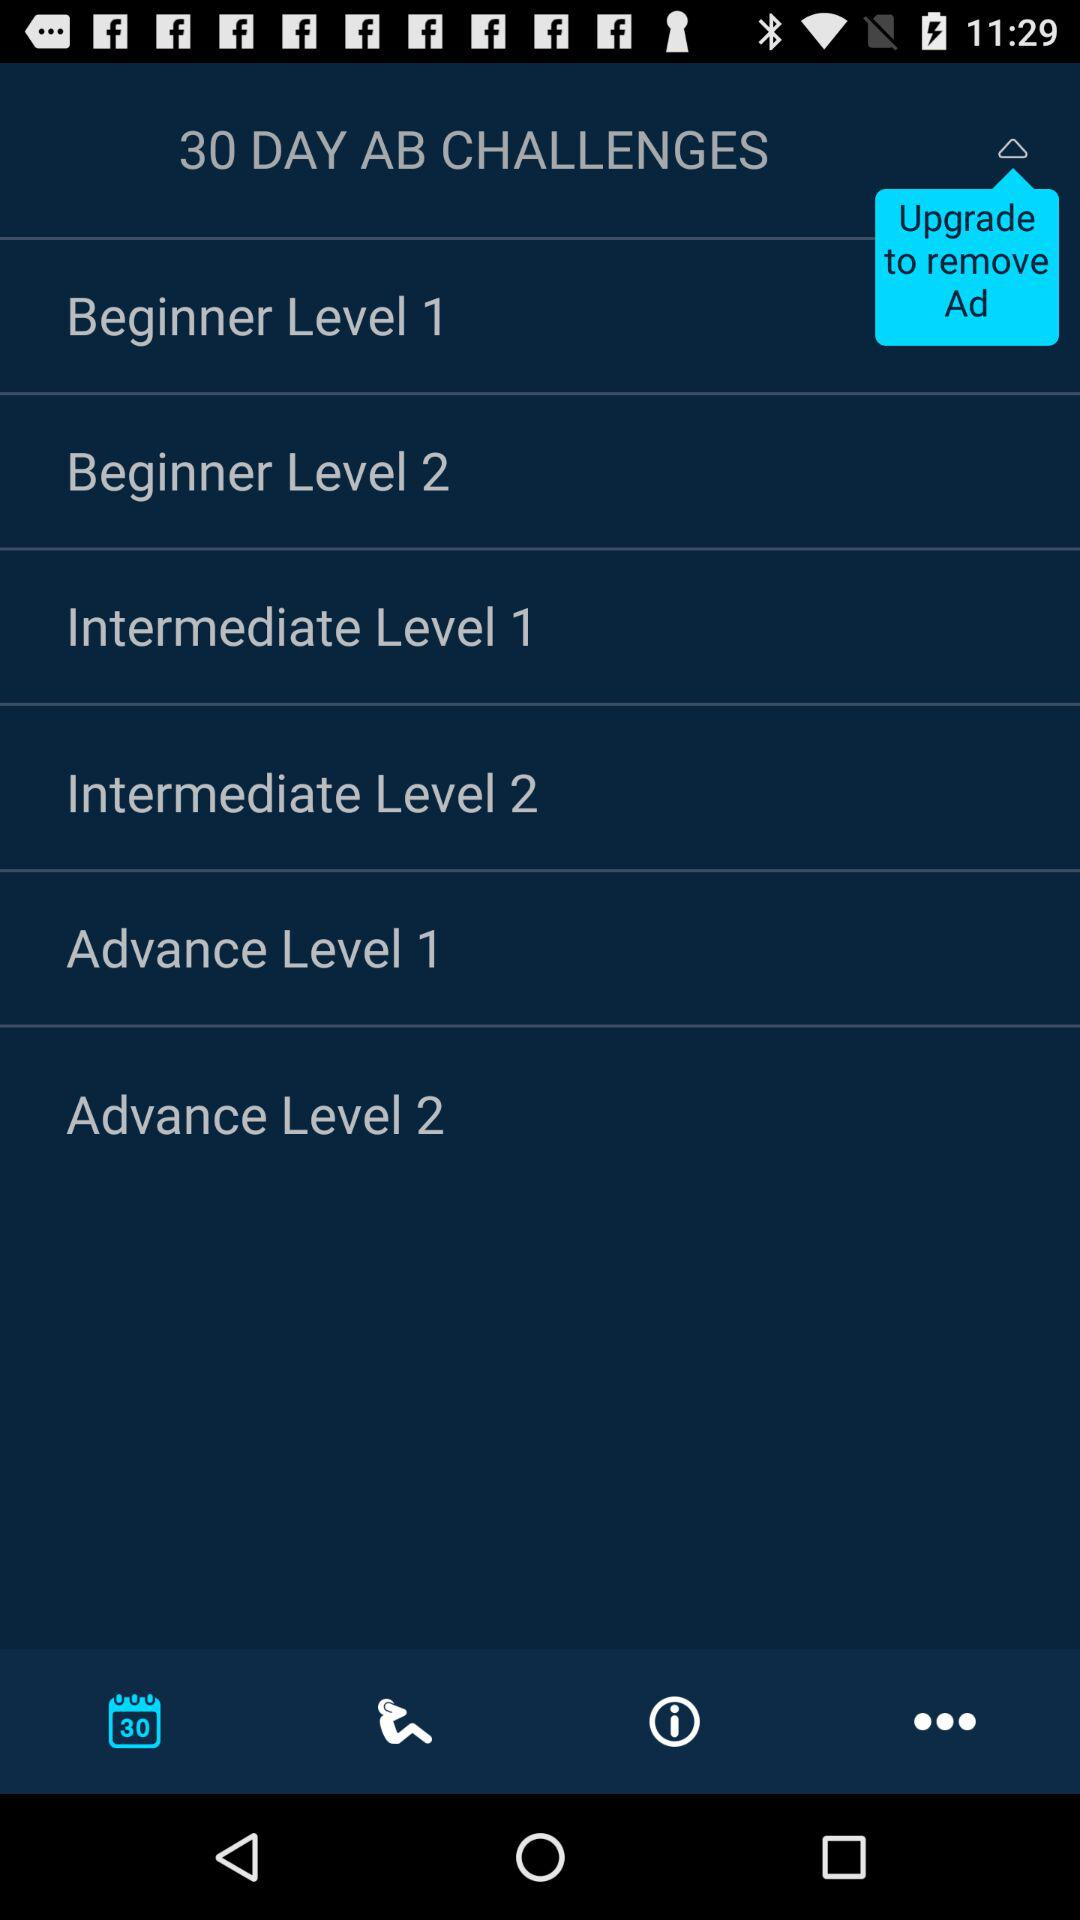How many levels are there for beginners?
Answer the question using a single word or phrase. 2 